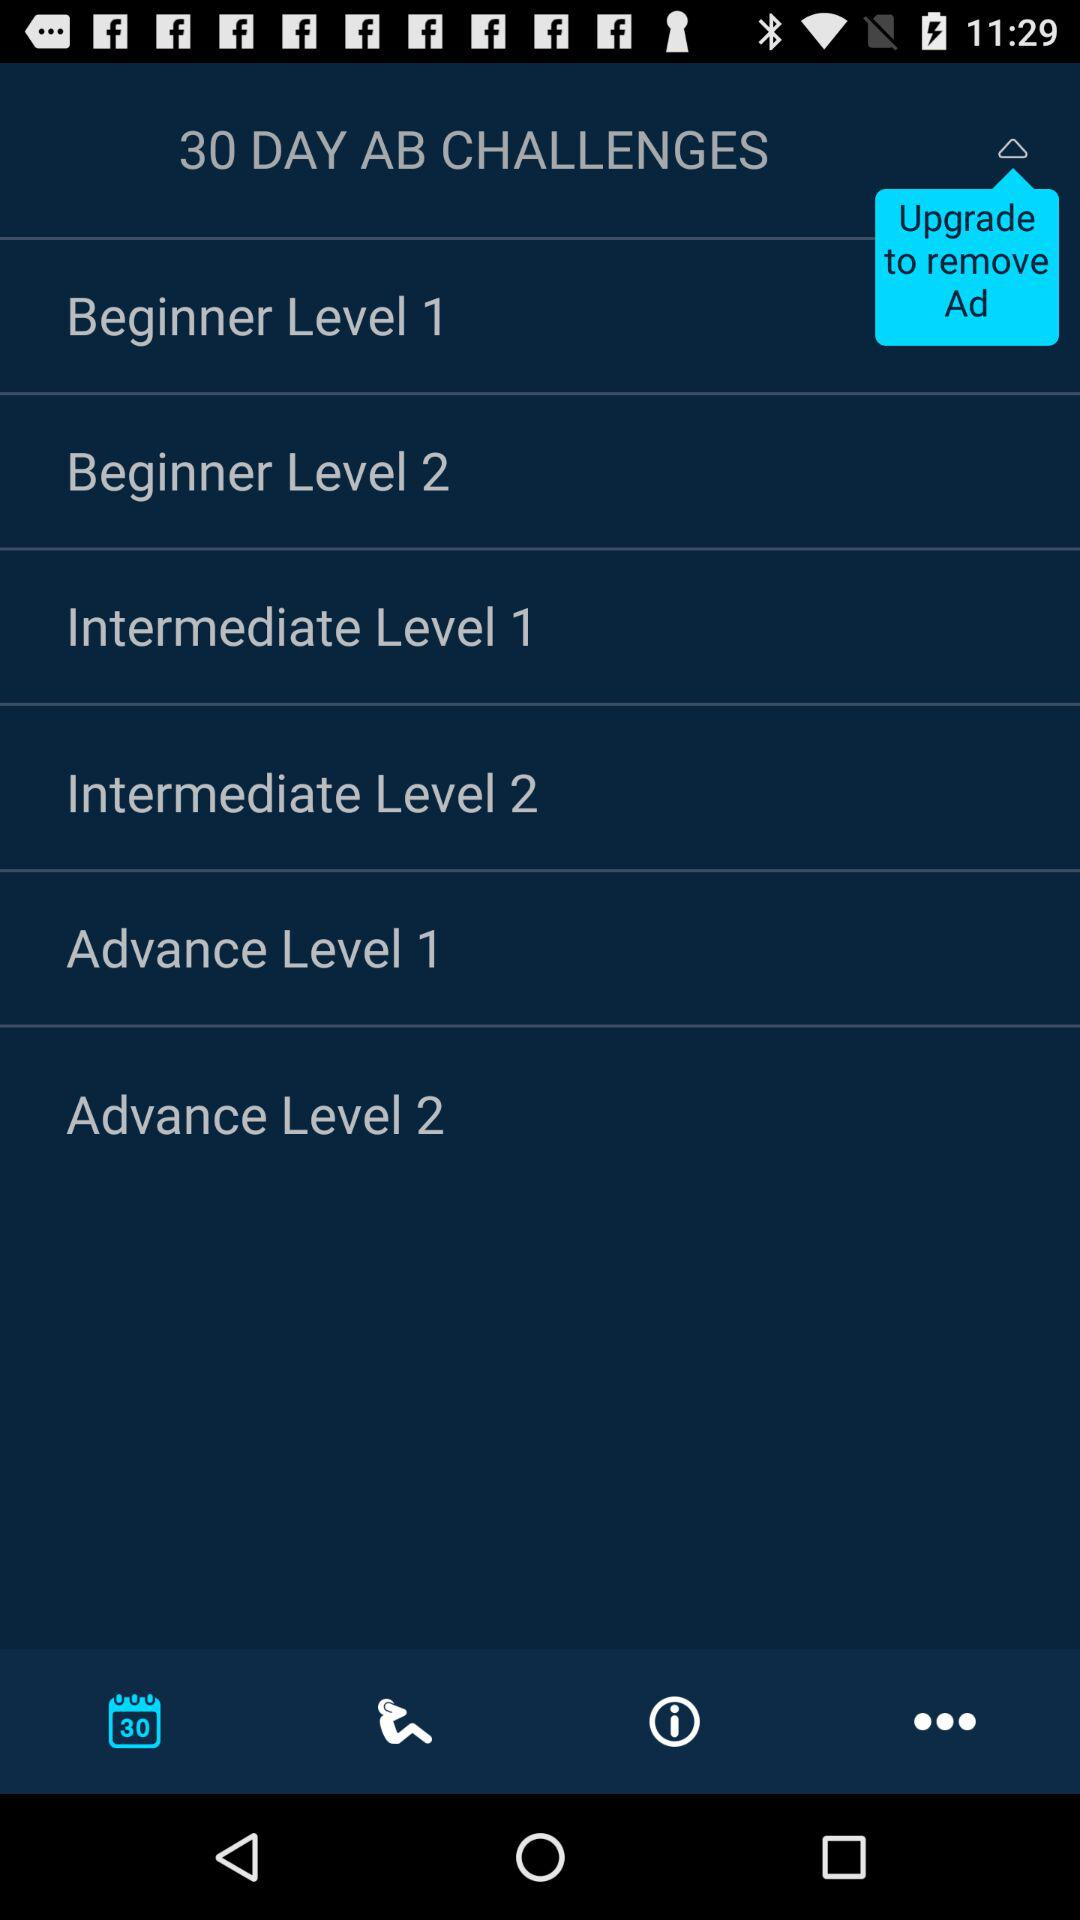How many levels are there for beginners?
Answer the question using a single word or phrase. 2 